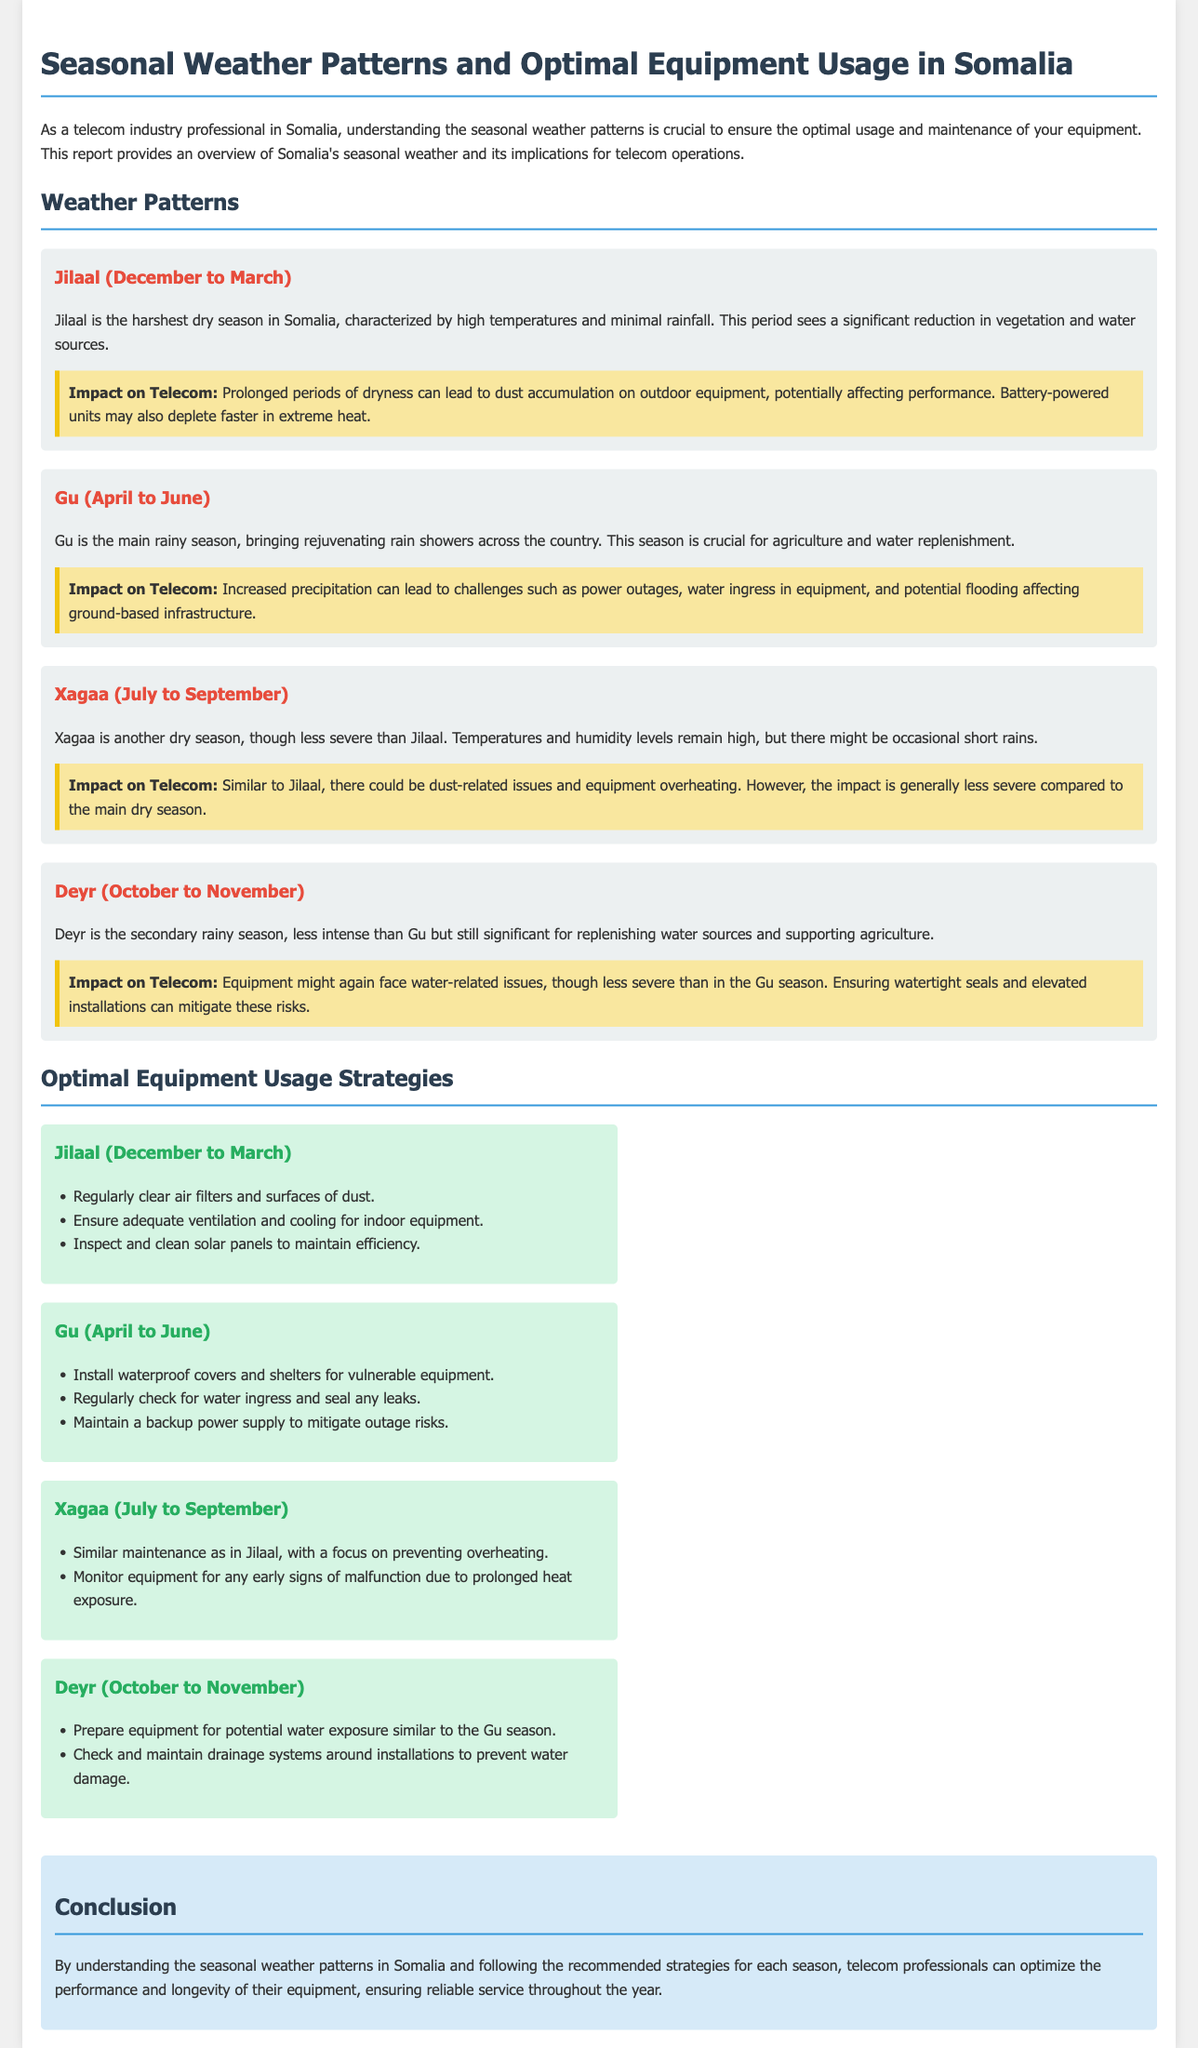What is the main rainy season in Somalia? The main rainy season in Somalia is called Gu, which lasts from April to June.
Answer: Gu What months does the Jilaal season occur? Jilaal occurs from December to March, making it the harshest dry season in Somalia.
Answer: December to March What impact does Gu have on telecom operations? Increased precipitation during Gu can lead to challenges such as power outages and water ingress in equipment.
Answer: Power outages, water ingress What maintenance strategy is recommended during the Jilaal season? During Jilaal, it is recommended to regularly clear air filters and surfaces of dust to prevent performance issues.
Answer: Regularly clear air filters How long does the Deyr season last? Deyr lasts from October to November, serving as a secondary rainy season.
Answer: October to November What is the impact of the Xagaa season on telecom? Xagaa can lead to dust-related issues and equipment overheating, though less severely compared to Jilaal.
Answer: Dust-related issues, overheating What is a recommended strategy for the Gu season? A recommended strategy during Gu is to regularly check for water ingress and seal any leaks to protect equipment.
Answer: Regularly check for water ingress What factors should be monitored in the Xagaa season? In the Xagaa season, equipment should be monitored for any early signs of malfunction due to prolonged heat exposure.
Answer: Early signs of malfunction What is the purpose of understanding seasonal weather patterns? Understanding seasonal weather patterns helps telecom professionals optimize the performance and longevity of their equipment.
Answer: Optimize performance and longevity 